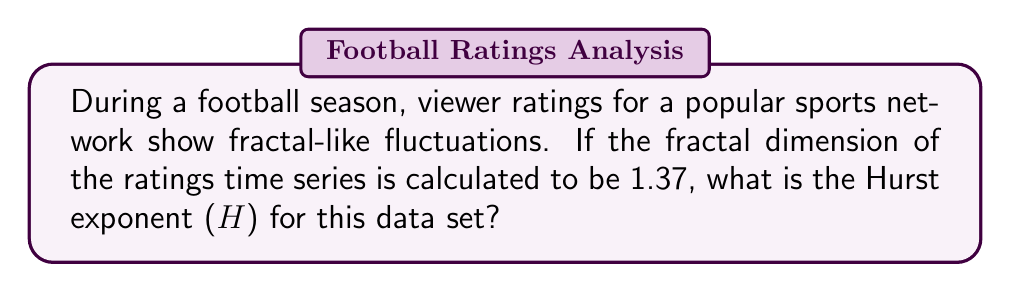Solve this math problem. To solve this problem, we need to understand the relationship between fractal dimension (D) and the Hurst exponent (H) in time series analysis. The steps are as follows:

1. Recall the formula relating fractal dimension (D) and Hurst exponent (H):
   
   $$D = 2 - H$$

2. We are given that the fractal dimension D = 1.37

3. Rearrange the formula to solve for H:
   
   $$H = 2 - D$$

4. Substitute the given value of D:
   
   $$H = 2 - 1.37$$

5. Calculate the result:
   
   $$H = 0.63$$

The Hurst exponent provides insights into the persistence or anti-persistence of the time series. In this case, H > 0.5 indicates that the viewer ratings have a tendency to persist in their trends, which could be valuable information for a sports network producer in predicting future rating patterns.
Answer: $H = 0.63$ 